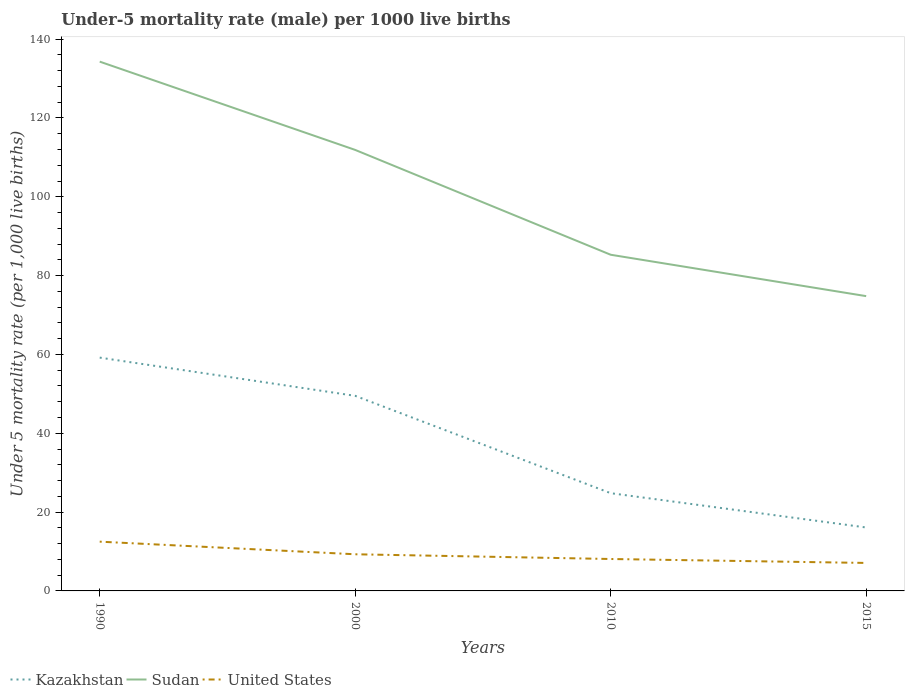How many different coloured lines are there?
Provide a succinct answer. 3. Is the number of lines equal to the number of legend labels?
Offer a terse response. Yes. Across all years, what is the maximum under-five mortality rate in Kazakhstan?
Make the answer very short. 16.1. In which year was the under-five mortality rate in Sudan maximum?
Provide a short and direct response. 2015. What is the total under-five mortality rate in Sudan in the graph?
Offer a terse response. 22.4. How many lines are there?
Make the answer very short. 3. Are the values on the major ticks of Y-axis written in scientific E-notation?
Your answer should be very brief. No. How many legend labels are there?
Offer a terse response. 3. What is the title of the graph?
Provide a succinct answer. Under-5 mortality rate (male) per 1000 live births. What is the label or title of the X-axis?
Offer a very short reply. Years. What is the label or title of the Y-axis?
Your answer should be very brief. Under 5 mortality rate (per 1,0 live births). What is the Under 5 mortality rate (per 1,000 live births) of Kazakhstan in 1990?
Your answer should be very brief. 59.2. What is the Under 5 mortality rate (per 1,000 live births) of Sudan in 1990?
Give a very brief answer. 134.3. What is the Under 5 mortality rate (per 1,000 live births) of United States in 1990?
Your answer should be compact. 12.5. What is the Under 5 mortality rate (per 1,000 live births) of Kazakhstan in 2000?
Provide a succinct answer. 49.5. What is the Under 5 mortality rate (per 1,000 live births) in Sudan in 2000?
Offer a very short reply. 111.9. What is the Under 5 mortality rate (per 1,000 live births) in United States in 2000?
Offer a terse response. 9.3. What is the Under 5 mortality rate (per 1,000 live births) of Kazakhstan in 2010?
Make the answer very short. 24.8. What is the Under 5 mortality rate (per 1,000 live births) of Sudan in 2010?
Give a very brief answer. 85.3. What is the Under 5 mortality rate (per 1,000 live births) in Kazakhstan in 2015?
Ensure brevity in your answer.  16.1. What is the Under 5 mortality rate (per 1,000 live births) of Sudan in 2015?
Your answer should be compact. 74.8. Across all years, what is the maximum Under 5 mortality rate (per 1,000 live births) in Kazakhstan?
Offer a terse response. 59.2. Across all years, what is the maximum Under 5 mortality rate (per 1,000 live births) of Sudan?
Ensure brevity in your answer.  134.3. Across all years, what is the maximum Under 5 mortality rate (per 1,000 live births) of United States?
Give a very brief answer. 12.5. Across all years, what is the minimum Under 5 mortality rate (per 1,000 live births) of Kazakhstan?
Offer a very short reply. 16.1. Across all years, what is the minimum Under 5 mortality rate (per 1,000 live births) in Sudan?
Make the answer very short. 74.8. Across all years, what is the minimum Under 5 mortality rate (per 1,000 live births) in United States?
Offer a terse response. 7.1. What is the total Under 5 mortality rate (per 1,000 live births) of Kazakhstan in the graph?
Provide a short and direct response. 149.6. What is the total Under 5 mortality rate (per 1,000 live births) in Sudan in the graph?
Your response must be concise. 406.3. What is the difference between the Under 5 mortality rate (per 1,000 live births) of Sudan in 1990 and that in 2000?
Offer a terse response. 22.4. What is the difference between the Under 5 mortality rate (per 1,000 live births) of Kazakhstan in 1990 and that in 2010?
Give a very brief answer. 34.4. What is the difference between the Under 5 mortality rate (per 1,000 live births) of United States in 1990 and that in 2010?
Give a very brief answer. 4.4. What is the difference between the Under 5 mortality rate (per 1,000 live births) of Kazakhstan in 1990 and that in 2015?
Provide a short and direct response. 43.1. What is the difference between the Under 5 mortality rate (per 1,000 live births) of Sudan in 1990 and that in 2015?
Provide a succinct answer. 59.5. What is the difference between the Under 5 mortality rate (per 1,000 live births) of United States in 1990 and that in 2015?
Make the answer very short. 5.4. What is the difference between the Under 5 mortality rate (per 1,000 live births) in Kazakhstan in 2000 and that in 2010?
Your answer should be compact. 24.7. What is the difference between the Under 5 mortality rate (per 1,000 live births) of Sudan in 2000 and that in 2010?
Give a very brief answer. 26.6. What is the difference between the Under 5 mortality rate (per 1,000 live births) of Kazakhstan in 2000 and that in 2015?
Offer a very short reply. 33.4. What is the difference between the Under 5 mortality rate (per 1,000 live births) in Sudan in 2000 and that in 2015?
Your response must be concise. 37.1. What is the difference between the Under 5 mortality rate (per 1,000 live births) in Sudan in 2010 and that in 2015?
Ensure brevity in your answer.  10.5. What is the difference between the Under 5 mortality rate (per 1,000 live births) in United States in 2010 and that in 2015?
Keep it short and to the point. 1. What is the difference between the Under 5 mortality rate (per 1,000 live births) of Kazakhstan in 1990 and the Under 5 mortality rate (per 1,000 live births) of Sudan in 2000?
Your answer should be compact. -52.7. What is the difference between the Under 5 mortality rate (per 1,000 live births) in Kazakhstan in 1990 and the Under 5 mortality rate (per 1,000 live births) in United States in 2000?
Make the answer very short. 49.9. What is the difference between the Under 5 mortality rate (per 1,000 live births) in Sudan in 1990 and the Under 5 mortality rate (per 1,000 live births) in United States in 2000?
Offer a terse response. 125. What is the difference between the Under 5 mortality rate (per 1,000 live births) of Kazakhstan in 1990 and the Under 5 mortality rate (per 1,000 live births) of Sudan in 2010?
Your answer should be compact. -26.1. What is the difference between the Under 5 mortality rate (per 1,000 live births) in Kazakhstan in 1990 and the Under 5 mortality rate (per 1,000 live births) in United States in 2010?
Your answer should be very brief. 51.1. What is the difference between the Under 5 mortality rate (per 1,000 live births) of Sudan in 1990 and the Under 5 mortality rate (per 1,000 live births) of United States in 2010?
Make the answer very short. 126.2. What is the difference between the Under 5 mortality rate (per 1,000 live births) of Kazakhstan in 1990 and the Under 5 mortality rate (per 1,000 live births) of Sudan in 2015?
Provide a succinct answer. -15.6. What is the difference between the Under 5 mortality rate (per 1,000 live births) in Kazakhstan in 1990 and the Under 5 mortality rate (per 1,000 live births) in United States in 2015?
Ensure brevity in your answer.  52.1. What is the difference between the Under 5 mortality rate (per 1,000 live births) of Sudan in 1990 and the Under 5 mortality rate (per 1,000 live births) of United States in 2015?
Ensure brevity in your answer.  127.2. What is the difference between the Under 5 mortality rate (per 1,000 live births) in Kazakhstan in 2000 and the Under 5 mortality rate (per 1,000 live births) in Sudan in 2010?
Make the answer very short. -35.8. What is the difference between the Under 5 mortality rate (per 1,000 live births) in Kazakhstan in 2000 and the Under 5 mortality rate (per 1,000 live births) in United States in 2010?
Make the answer very short. 41.4. What is the difference between the Under 5 mortality rate (per 1,000 live births) of Sudan in 2000 and the Under 5 mortality rate (per 1,000 live births) of United States in 2010?
Your answer should be very brief. 103.8. What is the difference between the Under 5 mortality rate (per 1,000 live births) of Kazakhstan in 2000 and the Under 5 mortality rate (per 1,000 live births) of Sudan in 2015?
Give a very brief answer. -25.3. What is the difference between the Under 5 mortality rate (per 1,000 live births) of Kazakhstan in 2000 and the Under 5 mortality rate (per 1,000 live births) of United States in 2015?
Your answer should be very brief. 42.4. What is the difference between the Under 5 mortality rate (per 1,000 live births) in Sudan in 2000 and the Under 5 mortality rate (per 1,000 live births) in United States in 2015?
Offer a very short reply. 104.8. What is the difference between the Under 5 mortality rate (per 1,000 live births) of Kazakhstan in 2010 and the Under 5 mortality rate (per 1,000 live births) of Sudan in 2015?
Provide a succinct answer. -50. What is the difference between the Under 5 mortality rate (per 1,000 live births) of Kazakhstan in 2010 and the Under 5 mortality rate (per 1,000 live births) of United States in 2015?
Your response must be concise. 17.7. What is the difference between the Under 5 mortality rate (per 1,000 live births) of Sudan in 2010 and the Under 5 mortality rate (per 1,000 live births) of United States in 2015?
Provide a short and direct response. 78.2. What is the average Under 5 mortality rate (per 1,000 live births) of Kazakhstan per year?
Your answer should be very brief. 37.4. What is the average Under 5 mortality rate (per 1,000 live births) of Sudan per year?
Keep it short and to the point. 101.58. What is the average Under 5 mortality rate (per 1,000 live births) in United States per year?
Keep it short and to the point. 9.25. In the year 1990, what is the difference between the Under 5 mortality rate (per 1,000 live births) in Kazakhstan and Under 5 mortality rate (per 1,000 live births) in Sudan?
Keep it short and to the point. -75.1. In the year 1990, what is the difference between the Under 5 mortality rate (per 1,000 live births) of Kazakhstan and Under 5 mortality rate (per 1,000 live births) of United States?
Make the answer very short. 46.7. In the year 1990, what is the difference between the Under 5 mortality rate (per 1,000 live births) in Sudan and Under 5 mortality rate (per 1,000 live births) in United States?
Your answer should be compact. 121.8. In the year 2000, what is the difference between the Under 5 mortality rate (per 1,000 live births) of Kazakhstan and Under 5 mortality rate (per 1,000 live births) of Sudan?
Provide a succinct answer. -62.4. In the year 2000, what is the difference between the Under 5 mortality rate (per 1,000 live births) in Kazakhstan and Under 5 mortality rate (per 1,000 live births) in United States?
Your answer should be very brief. 40.2. In the year 2000, what is the difference between the Under 5 mortality rate (per 1,000 live births) of Sudan and Under 5 mortality rate (per 1,000 live births) of United States?
Offer a terse response. 102.6. In the year 2010, what is the difference between the Under 5 mortality rate (per 1,000 live births) of Kazakhstan and Under 5 mortality rate (per 1,000 live births) of Sudan?
Your answer should be compact. -60.5. In the year 2010, what is the difference between the Under 5 mortality rate (per 1,000 live births) of Kazakhstan and Under 5 mortality rate (per 1,000 live births) of United States?
Provide a succinct answer. 16.7. In the year 2010, what is the difference between the Under 5 mortality rate (per 1,000 live births) of Sudan and Under 5 mortality rate (per 1,000 live births) of United States?
Offer a terse response. 77.2. In the year 2015, what is the difference between the Under 5 mortality rate (per 1,000 live births) of Kazakhstan and Under 5 mortality rate (per 1,000 live births) of Sudan?
Your response must be concise. -58.7. In the year 2015, what is the difference between the Under 5 mortality rate (per 1,000 live births) in Kazakhstan and Under 5 mortality rate (per 1,000 live births) in United States?
Your answer should be very brief. 9. In the year 2015, what is the difference between the Under 5 mortality rate (per 1,000 live births) of Sudan and Under 5 mortality rate (per 1,000 live births) of United States?
Provide a short and direct response. 67.7. What is the ratio of the Under 5 mortality rate (per 1,000 live births) of Kazakhstan in 1990 to that in 2000?
Make the answer very short. 1.2. What is the ratio of the Under 5 mortality rate (per 1,000 live births) in Sudan in 1990 to that in 2000?
Keep it short and to the point. 1.2. What is the ratio of the Under 5 mortality rate (per 1,000 live births) in United States in 1990 to that in 2000?
Offer a terse response. 1.34. What is the ratio of the Under 5 mortality rate (per 1,000 live births) of Kazakhstan in 1990 to that in 2010?
Your response must be concise. 2.39. What is the ratio of the Under 5 mortality rate (per 1,000 live births) of Sudan in 1990 to that in 2010?
Provide a succinct answer. 1.57. What is the ratio of the Under 5 mortality rate (per 1,000 live births) in United States in 1990 to that in 2010?
Your answer should be compact. 1.54. What is the ratio of the Under 5 mortality rate (per 1,000 live births) of Kazakhstan in 1990 to that in 2015?
Your answer should be compact. 3.68. What is the ratio of the Under 5 mortality rate (per 1,000 live births) of Sudan in 1990 to that in 2015?
Ensure brevity in your answer.  1.8. What is the ratio of the Under 5 mortality rate (per 1,000 live births) of United States in 1990 to that in 2015?
Your answer should be very brief. 1.76. What is the ratio of the Under 5 mortality rate (per 1,000 live births) of Kazakhstan in 2000 to that in 2010?
Your answer should be compact. 2. What is the ratio of the Under 5 mortality rate (per 1,000 live births) in Sudan in 2000 to that in 2010?
Provide a short and direct response. 1.31. What is the ratio of the Under 5 mortality rate (per 1,000 live births) of United States in 2000 to that in 2010?
Provide a short and direct response. 1.15. What is the ratio of the Under 5 mortality rate (per 1,000 live births) of Kazakhstan in 2000 to that in 2015?
Ensure brevity in your answer.  3.07. What is the ratio of the Under 5 mortality rate (per 1,000 live births) of Sudan in 2000 to that in 2015?
Provide a succinct answer. 1.5. What is the ratio of the Under 5 mortality rate (per 1,000 live births) in United States in 2000 to that in 2015?
Make the answer very short. 1.31. What is the ratio of the Under 5 mortality rate (per 1,000 live births) of Kazakhstan in 2010 to that in 2015?
Your answer should be compact. 1.54. What is the ratio of the Under 5 mortality rate (per 1,000 live births) of Sudan in 2010 to that in 2015?
Make the answer very short. 1.14. What is the ratio of the Under 5 mortality rate (per 1,000 live births) of United States in 2010 to that in 2015?
Provide a succinct answer. 1.14. What is the difference between the highest and the second highest Under 5 mortality rate (per 1,000 live births) of Kazakhstan?
Ensure brevity in your answer.  9.7. What is the difference between the highest and the second highest Under 5 mortality rate (per 1,000 live births) in Sudan?
Offer a terse response. 22.4. What is the difference between the highest and the lowest Under 5 mortality rate (per 1,000 live births) of Kazakhstan?
Keep it short and to the point. 43.1. What is the difference between the highest and the lowest Under 5 mortality rate (per 1,000 live births) of Sudan?
Make the answer very short. 59.5. 